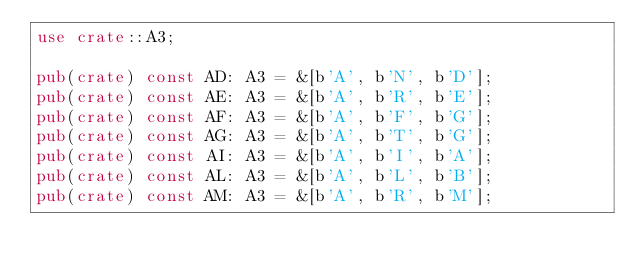<code> <loc_0><loc_0><loc_500><loc_500><_Rust_>use crate::A3;

pub(crate) const AD: A3 = &[b'A', b'N', b'D'];
pub(crate) const AE: A3 = &[b'A', b'R', b'E'];
pub(crate) const AF: A3 = &[b'A', b'F', b'G'];
pub(crate) const AG: A3 = &[b'A', b'T', b'G'];
pub(crate) const AI: A3 = &[b'A', b'I', b'A'];
pub(crate) const AL: A3 = &[b'A', b'L', b'B'];
pub(crate) const AM: A3 = &[b'A', b'R', b'M'];</code> 